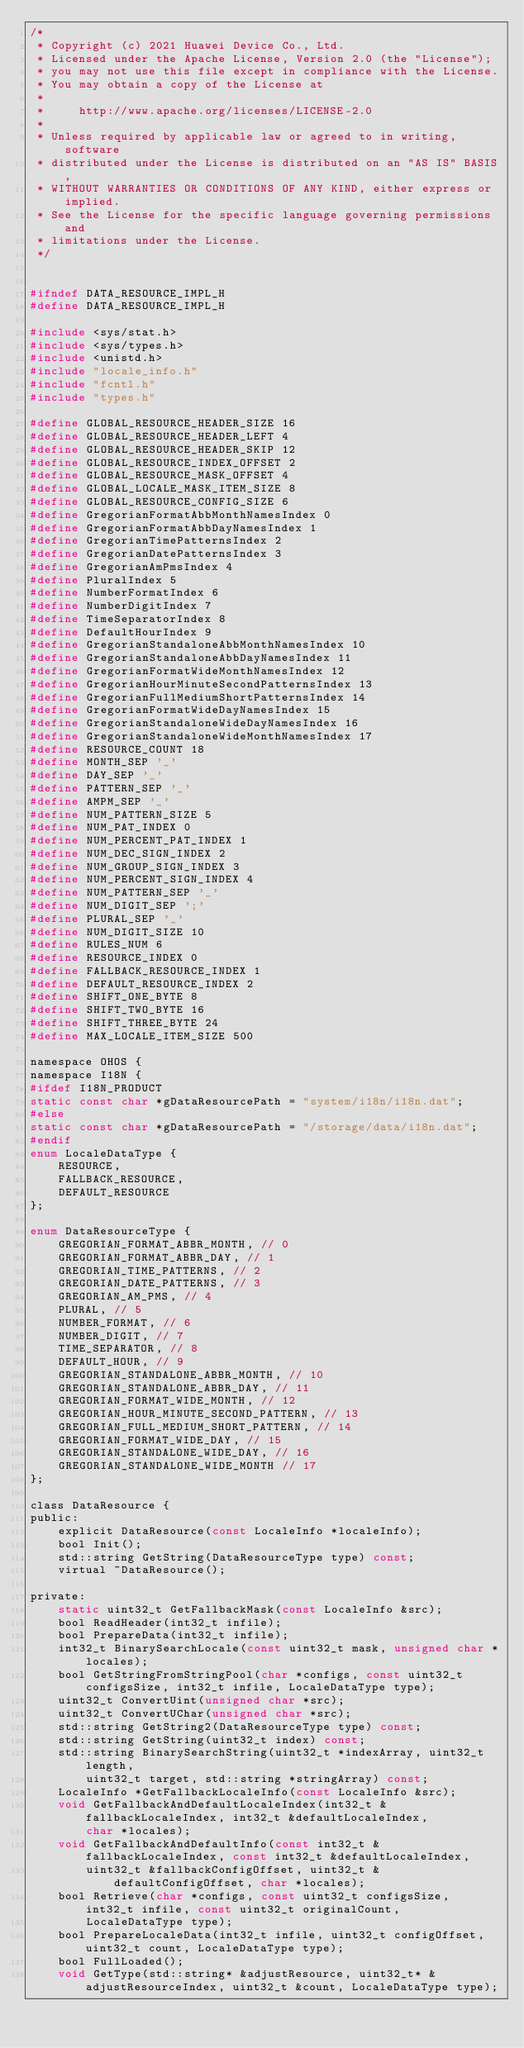<code> <loc_0><loc_0><loc_500><loc_500><_C_>/*
 * Copyright (c) 2021 Huawei Device Co., Ltd.
 * Licensed under the Apache License, Version 2.0 (the "License");
 * you may not use this file except in compliance with the License.
 * You may obtain a copy of the License at
 *
 *     http://www.apache.org/licenses/LICENSE-2.0
 *
 * Unless required by applicable law or agreed to in writing, software
 * distributed under the License is distributed on an "AS IS" BASIS,
 * WITHOUT WARRANTIES OR CONDITIONS OF ANY KIND, either express or implied.
 * See the License for the specific language governing permissions and
 * limitations under the License.
 */


#ifndef DATA_RESOURCE_IMPL_H
#define DATA_RESOURCE_IMPL_H

#include <sys/stat.h>
#include <sys/types.h>
#include <unistd.h>
#include "locale_info.h"
#include "fcntl.h"
#include "types.h"

#define GLOBAL_RESOURCE_HEADER_SIZE 16
#define GLOBAL_RESOURCE_HEADER_LEFT 4
#define GLOBAL_RESOURCE_HEADER_SKIP 12
#define GLOBAL_RESOURCE_INDEX_OFFSET 2
#define GLOBAL_RESOURCE_MASK_OFFSET 4
#define GLOBAL_LOCALE_MASK_ITEM_SIZE 8
#define GLOBAL_RESOURCE_CONFIG_SIZE 6
#define GregorianFormatAbbMonthNamesIndex 0
#define GregorianFormatAbbDayNamesIndex 1
#define GregorianTimePatternsIndex 2
#define GregorianDatePatternsIndex 3
#define GregorianAmPmsIndex 4
#define PluralIndex 5
#define NumberFormatIndex 6
#define NumberDigitIndex 7
#define TimeSeparatorIndex 8
#define DefaultHourIndex 9
#define GregorianStandaloneAbbMonthNamesIndex 10
#define GregorianStandaloneAbbDayNamesIndex 11
#define GregorianFormatWideMonthNamesIndex 12
#define GregorianHourMinuteSecondPatternsIndex 13
#define GregorianFullMediumShortPatternsIndex 14
#define GregorianFormatWideDayNamesIndex 15
#define GregorianStandaloneWideDayNamesIndex 16
#define GregorianStandaloneWideMonthNamesIndex 17
#define RESOURCE_COUNT 18
#define MONTH_SEP '_'
#define DAY_SEP '_'
#define PATTERN_SEP '_'
#define AMPM_SEP '_'
#define NUM_PATTERN_SIZE 5
#define NUM_PAT_INDEX 0
#define NUM_PERCENT_PAT_INDEX 1
#define NUM_DEC_SIGN_INDEX 2
#define NUM_GROUP_SIGN_INDEX 3
#define NUM_PERCENT_SIGN_INDEX 4
#define NUM_PATTERN_SEP '_'
#define NUM_DIGIT_SEP ';'
#define PLURAL_SEP '_'
#define NUM_DIGIT_SIZE 10
#define RULES_NUM 6
#define RESOURCE_INDEX 0
#define FALLBACK_RESOURCE_INDEX 1
#define DEFAULT_RESOURCE_INDEX 2
#define SHIFT_ONE_BYTE 8
#define SHIFT_TWO_BYTE 16
#define SHIFT_THREE_BYTE 24
#define MAX_LOCALE_ITEM_SIZE 500

namespace OHOS {
namespace I18N {
#ifdef I18N_PRODUCT
static const char *gDataResourcePath = "system/i18n/i18n.dat";
#else
static const char *gDataResourcePath = "/storage/data/i18n.dat";
#endif
enum LocaleDataType {
    RESOURCE,
    FALLBACK_RESOURCE,
    DEFAULT_RESOURCE
};

enum DataResourceType {
    GREGORIAN_FORMAT_ABBR_MONTH, // 0
    GREGORIAN_FORMAT_ABBR_DAY, // 1
    GREGORIAN_TIME_PATTERNS, // 2
    GREGORIAN_DATE_PATTERNS, // 3
    GREGORIAN_AM_PMS, // 4
    PLURAL, // 5
    NUMBER_FORMAT, // 6
    NUMBER_DIGIT, // 7
    TIME_SEPARATOR, // 8
    DEFAULT_HOUR, // 9
    GREGORIAN_STANDALONE_ABBR_MONTH, // 10
    GREGORIAN_STANDALONE_ABBR_DAY, // 11
    GREGORIAN_FORMAT_WIDE_MONTH, // 12
    GREGORIAN_HOUR_MINUTE_SECOND_PATTERN, // 13
    GREGORIAN_FULL_MEDIUM_SHORT_PATTERN, // 14
    GREGORIAN_FORMAT_WIDE_DAY, // 15
    GREGORIAN_STANDALONE_WIDE_DAY, // 16
    GREGORIAN_STANDALONE_WIDE_MONTH // 17
};

class DataResource {
public:
    explicit DataResource(const LocaleInfo *localeInfo);
    bool Init();
    std::string GetString(DataResourceType type) const;
    virtual ~DataResource();

private:
    static uint32_t GetFallbackMask(const LocaleInfo &src);
    bool ReadHeader(int32_t infile);
    bool PrepareData(int32_t infile);
    int32_t BinarySearchLocale(const uint32_t mask, unsigned char *locales);
    bool GetStringFromStringPool(char *configs, const uint32_t configsSize, int32_t infile, LocaleDataType type);
    uint32_t ConvertUint(unsigned char *src);
    uint32_t ConvertUChar(unsigned char *src);
    std::string GetString2(DataResourceType type) const;
    std::string GetString(uint32_t index) const;
    std::string BinarySearchString(uint32_t *indexArray, uint32_t length,
        uint32_t target, std::string *stringArray) const;
    LocaleInfo *GetFallbackLocaleInfo(const LocaleInfo &src);
    void GetFallbackAndDefaultLocaleIndex(int32_t &fallbackLocaleIndex, int32_t &defaultLocaleIndex,
        char *locales);
    void GetFallbackAndDefaultInfo(const int32_t &fallbackLocaleIndex, const int32_t &defaultLocaleIndex,
        uint32_t &fallbackConfigOffset, uint32_t &defaultConfigOffset, char *locales);
    bool Retrieve(char *configs, const uint32_t configsSize, int32_t infile, const uint32_t originalCount,
        LocaleDataType type);
    bool PrepareLocaleData(int32_t infile, uint32_t configOffset, uint32_t count, LocaleDataType type);
    bool FullLoaded();
    void GetType(std::string* &adjustResource, uint32_t* &adjustResourceIndex, uint32_t &count, LocaleDataType type);</code> 